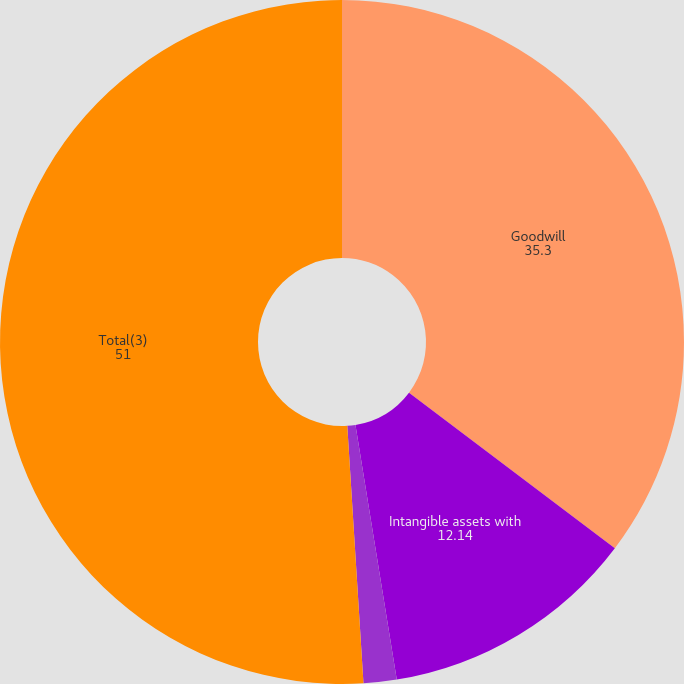<chart> <loc_0><loc_0><loc_500><loc_500><pie_chart><fcel>Goodwill<fcel>Intangible assets with<fcel>Net liabilities and<fcel>Total(3)<nl><fcel>35.3%<fcel>12.14%<fcel>1.56%<fcel>51.0%<nl></chart> 